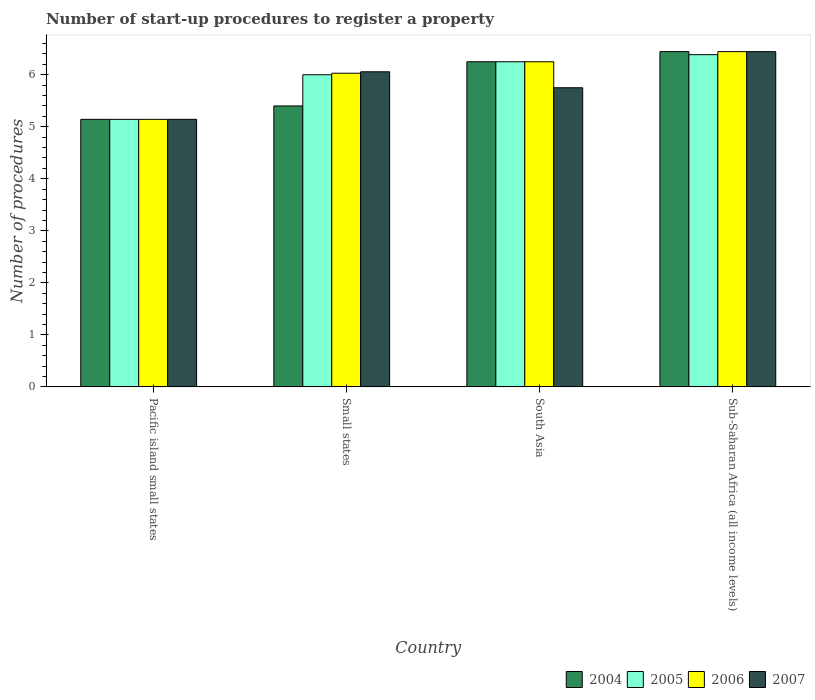How many different coloured bars are there?
Provide a succinct answer. 4. How many groups of bars are there?
Your answer should be very brief. 4. Are the number of bars per tick equal to the number of legend labels?
Ensure brevity in your answer.  Yes. Are the number of bars on each tick of the X-axis equal?
Make the answer very short. Yes. How many bars are there on the 4th tick from the right?
Give a very brief answer. 4. In how many cases, is the number of bars for a given country not equal to the number of legend labels?
Make the answer very short. 0. What is the number of procedures required to register a property in 2006 in Sub-Saharan Africa (all income levels)?
Your answer should be compact. 6.44. Across all countries, what is the maximum number of procedures required to register a property in 2005?
Your answer should be very brief. 6.39. Across all countries, what is the minimum number of procedures required to register a property in 2006?
Your answer should be compact. 5.14. In which country was the number of procedures required to register a property in 2006 maximum?
Your answer should be compact. Sub-Saharan Africa (all income levels). In which country was the number of procedures required to register a property in 2007 minimum?
Your response must be concise. Pacific island small states. What is the total number of procedures required to register a property in 2006 in the graph?
Provide a succinct answer. 23.87. What is the difference between the number of procedures required to register a property in 2004 in Pacific island small states and that in South Asia?
Your response must be concise. -1.11. What is the difference between the number of procedures required to register a property in 2005 in Sub-Saharan Africa (all income levels) and the number of procedures required to register a property in 2007 in Small states?
Your response must be concise. 0.33. What is the average number of procedures required to register a property in 2004 per country?
Make the answer very short. 5.81. What is the difference between the number of procedures required to register a property of/in 2006 and number of procedures required to register a property of/in 2007 in South Asia?
Offer a terse response. 0.5. In how many countries, is the number of procedures required to register a property in 2007 greater than 5.2?
Ensure brevity in your answer.  3. What is the ratio of the number of procedures required to register a property in 2005 in Small states to that in Sub-Saharan Africa (all income levels)?
Make the answer very short. 0.94. Is the difference between the number of procedures required to register a property in 2006 in Pacific island small states and South Asia greater than the difference between the number of procedures required to register a property in 2007 in Pacific island small states and South Asia?
Give a very brief answer. No. What is the difference between the highest and the second highest number of procedures required to register a property in 2006?
Provide a short and direct response. -0.42. What is the difference between the highest and the lowest number of procedures required to register a property in 2005?
Offer a terse response. 1.24. What does the 2nd bar from the right in Pacific island small states represents?
Your answer should be very brief. 2006. Is it the case that in every country, the sum of the number of procedures required to register a property in 2007 and number of procedures required to register a property in 2006 is greater than the number of procedures required to register a property in 2005?
Provide a succinct answer. Yes. How many bars are there?
Provide a short and direct response. 16. Are all the bars in the graph horizontal?
Your response must be concise. No. How many countries are there in the graph?
Make the answer very short. 4. What is the difference between two consecutive major ticks on the Y-axis?
Keep it short and to the point. 1. Are the values on the major ticks of Y-axis written in scientific E-notation?
Your answer should be compact. No. Does the graph contain any zero values?
Your answer should be compact. No. Does the graph contain grids?
Your answer should be compact. No. Where does the legend appear in the graph?
Offer a very short reply. Bottom right. What is the title of the graph?
Make the answer very short. Number of start-up procedures to register a property. Does "1991" appear as one of the legend labels in the graph?
Your response must be concise. No. What is the label or title of the X-axis?
Your answer should be compact. Country. What is the label or title of the Y-axis?
Your answer should be compact. Number of procedures. What is the Number of procedures in 2004 in Pacific island small states?
Make the answer very short. 5.14. What is the Number of procedures in 2005 in Pacific island small states?
Make the answer very short. 5.14. What is the Number of procedures of 2006 in Pacific island small states?
Provide a succinct answer. 5.14. What is the Number of procedures in 2007 in Pacific island small states?
Your answer should be compact. 5.14. What is the Number of procedures in 2004 in Small states?
Keep it short and to the point. 5.4. What is the Number of procedures in 2006 in Small states?
Your response must be concise. 6.03. What is the Number of procedures in 2007 in Small states?
Offer a terse response. 6.06. What is the Number of procedures in 2004 in South Asia?
Provide a short and direct response. 6.25. What is the Number of procedures of 2005 in South Asia?
Provide a short and direct response. 6.25. What is the Number of procedures in 2006 in South Asia?
Your answer should be very brief. 6.25. What is the Number of procedures in 2007 in South Asia?
Offer a very short reply. 5.75. What is the Number of procedures of 2004 in Sub-Saharan Africa (all income levels)?
Provide a short and direct response. 6.44. What is the Number of procedures of 2005 in Sub-Saharan Africa (all income levels)?
Your answer should be very brief. 6.39. What is the Number of procedures of 2006 in Sub-Saharan Africa (all income levels)?
Keep it short and to the point. 6.44. What is the Number of procedures in 2007 in Sub-Saharan Africa (all income levels)?
Your response must be concise. 6.44. Across all countries, what is the maximum Number of procedures of 2004?
Keep it short and to the point. 6.44. Across all countries, what is the maximum Number of procedures in 2005?
Offer a terse response. 6.39. Across all countries, what is the maximum Number of procedures of 2006?
Make the answer very short. 6.44. Across all countries, what is the maximum Number of procedures in 2007?
Your response must be concise. 6.44. Across all countries, what is the minimum Number of procedures of 2004?
Your response must be concise. 5.14. Across all countries, what is the minimum Number of procedures in 2005?
Your answer should be very brief. 5.14. Across all countries, what is the minimum Number of procedures in 2006?
Give a very brief answer. 5.14. Across all countries, what is the minimum Number of procedures in 2007?
Keep it short and to the point. 5.14. What is the total Number of procedures in 2004 in the graph?
Provide a succinct answer. 23.24. What is the total Number of procedures of 2005 in the graph?
Provide a short and direct response. 23.78. What is the total Number of procedures in 2006 in the graph?
Your answer should be compact. 23.87. What is the total Number of procedures in 2007 in the graph?
Your answer should be very brief. 23.39. What is the difference between the Number of procedures in 2004 in Pacific island small states and that in Small states?
Keep it short and to the point. -0.26. What is the difference between the Number of procedures of 2005 in Pacific island small states and that in Small states?
Offer a very short reply. -0.86. What is the difference between the Number of procedures of 2006 in Pacific island small states and that in Small states?
Offer a very short reply. -0.89. What is the difference between the Number of procedures in 2007 in Pacific island small states and that in Small states?
Keep it short and to the point. -0.91. What is the difference between the Number of procedures in 2004 in Pacific island small states and that in South Asia?
Keep it short and to the point. -1.11. What is the difference between the Number of procedures of 2005 in Pacific island small states and that in South Asia?
Provide a short and direct response. -1.11. What is the difference between the Number of procedures in 2006 in Pacific island small states and that in South Asia?
Your response must be concise. -1.11. What is the difference between the Number of procedures of 2007 in Pacific island small states and that in South Asia?
Your response must be concise. -0.61. What is the difference between the Number of procedures of 2004 in Pacific island small states and that in Sub-Saharan Africa (all income levels)?
Provide a short and direct response. -1.3. What is the difference between the Number of procedures in 2005 in Pacific island small states and that in Sub-Saharan Africa (all income levels)?
Your response must be concise. -1.24. What is the difference between the Number of procedures of 2006 in Pacific island small states and that in Sub-Saharan Africa (all income levels)?
Provide a short and direct response. -1.3. What is the difference between the Number of procedures of 2007 in Pacific island small states and that in Sub-Saharan Africa (all income levels)?
Your answer should be very brief. -1.3. What is the difference between the Number of procedures in 2004 in Small states and that in South Asia?
Keep it short and to the point. -0.85. What is the difference between the Number of procedures of 2005 in Small states and that in South Asia?
Keep it short and to the point. -0.25. What is the difference between the Number of procedures in 2006 in Small states and that in South Asia?
Your answer should be very brief. -0.22. What is the difference between the Number of procedures in 2007 in Small states and that in South Asia?
Ensure brevity in your answer.  0.31. What is the difference between the Number of procedures of 2004 in Small states and that in Sub-Saharan Africa (all income levels)?
Provide a short and direct response. -1.04. What is the difference between the Number of procedures of 2005 in Small states and that in Sub-Saharan Africa (all income levels)?
Provide a short and direct response. -0.39. What is the difference between the Number of procedures in 2006 in Small states and that in Sub-Saharan Africa (all income levels)?
Your response must be concise. -0.41. What is the difference between the Number of procedures of 2007 in Small states and that in Sub-Saharan Africa (all income levels)?
Your answer should be compact. -0.39. What is the difference between the Number of procedures of 2004 in South Asia and that in Sub-Saharan Africa (all income levels)?
Your response must be concise. -0.19. What is the difference between the Number of procedures of 2005 in South Asia and that in Sub-Saharan Africa (all income levels)?
Make the answer very short. -0.14. What is the difference between the Number of procedures in 2006 in South Asia and that in Sub-Saharan Africa (all income levels)?
Your response must be concise. -0.19. What is the difference between the Number of procedures of 2007 in South Asia and that in Sub-Saharan Africa (all income levels)?
Offer a very short reply. -0.69. What is the difference between the Number of procedures of 2004 in Pacific island small states and the Number of procedures of 2005 in Small states?
Make the answer very short. -0.86. What is the difference between the Number of procedures of 2004 in Pacific island small states and the Number of procedures of 2006 in Small states?
Your response must be concise. -0.89. What is the difference between the Number of procedures in 2004 in Pacific island small states and the Number of procedures in 2007 in Small states?
Ensure brevity in your answer.  -0.91. What is the difference between the Number of procedures of 2005 in Pacific island small states and the Number of procedures of 2006 in Small states?
Keep it short and to the point. -0.89. What is the difference between the Number of procedures of 2005 in Pacific island small states and the Number of procedures of 2007 in Small states?
Provide a succinct answer. -0.91. What is the difference between the Number of procedures of 2006 in Pacific island small states and the Number of procedures of 2007 in Small states?
Your answer should be compact. -0.91. What is the difference between the Number of procedures of 2004 in Pacific island small states and the Number of procedures of 2005 in South Asia?
Your answer should be compact. -1.11. What is the difference between the Number of procedures of 2004 in Pacific island small states and the Number of procedures of 2006 in South Asia?
Offer a very short reply. -1.11. What is the difference between the Number of procedures in 2004 in Pacific island small states and the Number of procedures in 2007 in South Asia?
Offer a very short reply. -0.61. What is the difference between the Number of procedures of 2005 in Pacific island small states and the Number of procedures of 2006 in South Asia?
Make the answer very short. -1.11. What is the difference between the Number of procedures in 2005 in Pacific island small states and the Number of procedures in 2007 in South Asia?
Ensure brevity in your answer.  -0.61. What is the difference between the Number of procedures in 2006 in Pacific island small states and the Number of procedures in 2007 in South Asia?
Make the answer very short. -0.61. What is the difference between the Number of procedures in 2004 in Pacific island small states and the Number of procedures in 2005 in Sub-Saharan Africa (all income levels)?
Your answer should be very brief. -1.24. What is the difference between the Number of procedures of 2004 in Pacific island small states and the Number of procedures of 2006 in Sub-Saharan Africa (all income levels)?
Make the answer very short. -1.3. What is the difference between the Number of procedures in 2004 in Pacific island small states and the Number of procedures in 2007 in Sub-Saharan Africa (all income levels)?
Your response must be concise. -1.3. What is the difference between the Number of procedures in 2005 in Pacific island small states and the Number of procedures in 2006 in Sub-Saharan Africa (all income levels)?
Your answer should be compact. -1.3. What is the difference between the Number of procedures in 2005 in Pacific island small states and the Number of procedures in 2007 in Sub-Saharan Africa (all income levels)?
Offer a very short reply. -1.3. What is the difference between the Number of procedures in 2006 in Pacific island small states and the Number of procedures in 2007 in Sub-Saharan Africa (all income levels)?
Provide a succinct answer. -1.3. What is the difference between the Number of procedures in 2004 in Small states and the Number of procedures in 2005 in South Asia?
Offer a very short reply. -0.85. What is the difference between the Number of procedures in 2004 in Small states and the Number of procedures in 2006 in South Asia?
Offer a terse response. -0.85. What is the difference between the Number of procedures in 2004 in Small states and the Number of procedures in 2007 in South Asia?
Provide a short and direct response. -0.35. What is the difference between the Number of procedures of 2005 in Small states and the Number of procedures of 2006 in South Asia?
Offer a terse response. -0.25. What is the difference between the Number of procedures of 2006 in Small states and the Number of procedures of 2007 in South Asia?
Provide a short and direct response. 0.28. What is the difference between the Number of procedures of 2004 in Small states and the Number of procedures of 2005 in Sub-Saharan Africa (all income levels)?
Give a very brief answer. -0.99. What is the difference between the Number of procedures in 2004 in Small states and the Number of procedures in 2006 in Sub-Saharan Africa (all income levels)?
Keep it short and to the point. -1.04. What is the difference between the Number of procedures of 2004 in Small states and the Number of procedures of 2007 in Sub-Saharan Africa (all income levels)?
Provide a short and direct response. -1.04. What is the difference between the Number of procedures in 2005 in Small states and the Number of procedures in 2006 in Sub-Saharan Africa (all income levels)?
Offer a terse response. -0.44. What is the difference between the Number of procedures in 2005 in Small states and the Number of procedures in 2007 in Sub-Saharan Africa (all income levels)?
Provide a short and direct response. -0.44. What is the difference between the Number of procedures in 2006 in Small states and the Number of procedures in 2007 in Sub-Saharan Africa (all income levels)?
Offer a very short reply. -0.41. What is the difference between the Number of procedures of 2004 in South Asia and the Number of procedures of 2005 in Sub-Saharan Africa (all income levels)?
Give a very brief answer. -0.14. What is the difference between the Number of procedures of 2004 in South Asia and the Number of procedures of 2006 in Sub-Saharan Africa (all income levels)?
Your answer should be compact. -0.19. What is the difference between the Number of procedures in 2004 in South Asia and the Number of procedures in 2007 in Sub-Saharan Africa (all income levels)?
Give a very brief answer. -0.19. What is the difference between the Number of procedures in 2005 in South Asia and the Number of procedures in 2006 in Sub-Saharan Africa (all income levels)?
Provide a short and direct response. -0.19. What is the difference between the Number of procedures in 2005 in South Asia and the Number of procedures in 2007 in Sub-Saharan Africa (all income levels)?
Provide a short and direct response. -0.19. What is the difference between the Number of procedures of 2006 in South Asia and the Number of procedures of 2007 in Sub-Saharan Africa (all income levels)?
Keep it short and to the point. -0.19. What is the average Number of procedures of 2004 per country?
Keep it short and to the point. 5.81. What is the average Number of procedures of 2005 per country?
Provide a succinct answer. 5.94. What is the average Number of procedures in 2006 per country?
Ensure brevity in your answer.  5.97. What is the average Number of procedures of 2007 per country?
Your answer should be very brief. 5.85. What is the difference between the Number of procedures in 2005 and Number of procedures in 2006 in Pacific island small states?
Give a very brief answer. 0. What is the difference between the Number of procedures of 2004 and Number of procedures of 2005 in Small states?
Provide a succinct answer. -0.6. What is the difference between the Number of procedures of 2004 and Number of procedures of 2006 in Small states?
Your answer should be very brief. -0.63. What is the difference between the Number of procedures in 2004 and Number of procedures in 2007 in Small states?
Provide a succinct answer. -0.66. What is the difference between the Number of procedures of 2005 and Number of procedures of 2006 in Small states?
Provide a short and direct response. -0.03. What is the difference between the Number of procedures of 2005 and Number of procedures of 2007 in Small states?
Ensure brevity in your answer.  -0.06. What is the difference between the Number of procedures of 2006 and Number of procedures of 2007 in Small states?
Provide a short and direct response. -0.03. What is the difference between the Number of procedures of 2004 and Number of procedures of 2006 in South Asia?
Your answer should be compact. 0. What is the difference between the Number of procedures in 2005 and Number of procedures in 2007 in South Asia?
Provide a short and direct response. 0.5. What is the difference between the Number of procedures in 2006 and Number of procedures in 2007 in South Asia?
Your response must be concise. 0.5. What is the difference between the Number of procedures in 2004 and Number of procedures in 2005 in Sub-Saharan Africa (all income levels)?
Your answer should be very brief. 0.06. What is the difference between the Number of procedures of 2004 and Number of procedures of 2007 in Sub-Saharan Africa (all income levels)?
Give a very brief answer. 0. What is the difference between the Number of procedures of 2005 and Number of procedures of 2006 in Sub-Saharan Africa (all income levels)?
Offer a very short reply. -0.06. What is the difference between the Number of procedures of 2005 and Number of procedures of 2007 in Sub-Saharan Africa (all income levels)?
Keep it short and to the point. -0.06. What is the difference between the Number of procedures in 2006 and Number of procedures in 2007 in Sub-Saharan Africa (all income levels)?
Offer a very short reply. 0. What is the ratio of the Number of procedures of 2005 in Pacific island small states to that in Small states?
Your answer should be very brief. 0.86. What is the ratio of the Number of procedures of 2006 in Pacific island small states to that in Small states?
Your answer should be compact. 0.85. What is the ratio of the Number of procedures in 2007 in Pacific island small states to that in Small states?
Your response must be concise. 0.85. What is the ratio of the Number of procedures of 2004 in Pacific island small states to that in South Asia?
Make the answer very short. 0.82. What is the ratio of the Number of procedures of 2005 in Pacific island small states to that in South Asia?
Ensure brevity in your answer.  0.82. What is the ratio of the Number of procedures of 2006 in Pacific island small states to that in South Asia?
Ensure brevity in your answer.  0.82. What is the ratio of the Number of procedures in 2007 in Pacific island small states to that in South Asia?
Offer a terse response. 0.89. What is the ratio of the Number of procedures of 2004 in Pacific island small states to that in Sub-Saharan Africa (all income levels)?
Provide a succinct answer. 0.8. What is the ratio of the Number of procedures in 2005 in Pacific island small states to that in Sub-Saharan Africa (all income levels)?
Your answer should be very brief. 0.81. What is the ratio of the Number of procedures in 2006 in Pacific island small states to that in Sub-Saharan Africa (all income levels)?
Make the answer very short. 0.8. What is the ratio of the Number of procedures of 2007 in Pacific island small states to that in Sub-Saharan Africa (all income levels)?
Keep it short and to the point. 0.8. What is the ratio of the Number of procedures in 2004 in Small states to that in South Asia?
Provide a short and direct response. 0.86. What is the ratio of the Number of procedures in 2005 in Small states to that in South Asia?
Your answer should be compact. 0.96. What is the ratio of the Number of procedures in 2006 in Small states to that in South Asia?
Ensure brevity in your answer.  0.96. What is the ratio of the Number of procedures of 2007 in Small states to that in South Asia?
Your answer should be compact. 1.05. What is the ratio of the Number of procedures of 2004 in Small states to that in Sub-Saharan Africa (all income levels)?
Make the answer very short. 0.84. What is the ratio of the Number of procedures in 2005 in Small states to that in Sub-Saharan Africa (all income levels)?
Offer a very short reply. 0.94. What is the ratio of the Number of procedures in 2006 in Small states to that in Sub-Saharan Africa (all income levels)?
Offer a terse response. 0.94. What is the ratio of the Number of procedures of 2007 in Small states to that in Sub-Saharan Africa (all income levels)?
Your answer should be compact. 0.94. What is the ratio of the Number of procedures of 2004 in South Asia to that in Sub-Saharan Africa (all income levels)?
Make the answer very short. 0.97. What is the ratio of the Number of procedures of 2005 in South Asia to that in Sub-Saharan Africa (all income levels)?
Your answer should be compact. 0.98. What is the ratio of the Number of procedures in 2006 in South Asia to that in Sub-Saharan Africa (all income levels)?
Provide a succinct answer. 0.97. What is the ratio of the Number of procedures in 2007 in South Asia to that in Sub-Saharan Africa (all income levels)?
Provide a succinct answer. 0.89. What is the difference between the highest and the second highest Number of procedures in 2004?
Your answer should be very brief. 0.19. What is the difference between the highest and the second highest Number of procedures of 2005?
Offer a terse response. 0.14. What is the difference between the highest and the second highest Number of procedures in 2006?
Make the answer very short. 0.19. What is the difference between the highest and the second highest Number of procedures of 2007?
Make the answer very short. 0.39. What is the difference between the highest and the lowest Number of procedures of 2004?
Provide a succinct answer. 1.3. What is the difference between the highest and the lowest Number of procedures of 2005?
Keep it short and to the point. 1.24. What is the difference between the highest and the lowest Number of procedures of 2006?
Offer a terse response. 1.3. What is the difference between the highest and the lowest Number of procedures of 2007?
Offer a terse response. 1.3. 